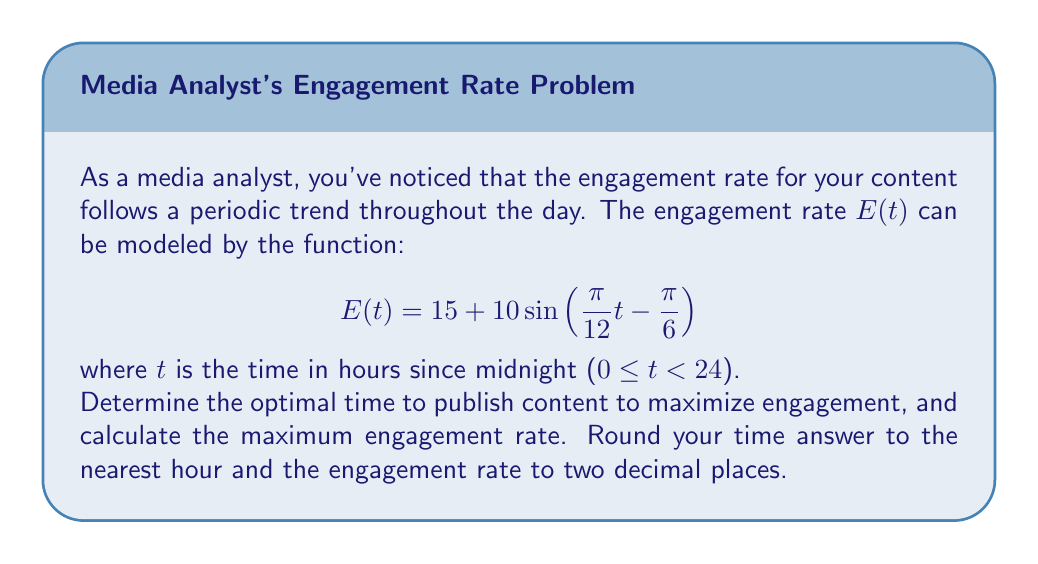Show me your answer to this math problem. To solve this problem, we'll follow these steps:

1) The function $E(t)$ is a sinusoidal function with a period of 24 hours. The optimal time to publish will be when this function reaches its maximum value.

2) For a sine function in the form $a\sin(bt - c) + d$, the maximum occurs when $bt - c = \frac{\pi}{2}$.

3) In our case, $b = \frac{\pi}{12}$, $c = \frac{\pi}{6}$, so we need to solve:

   $$\frac{\pi}{12}t - \frac{\pi}{6} = \frac{\pi}{2}$$

4) Solving for t:
   
   $$\frac{\pi}{12}t = \frac{\pi}{2} + \frac{\pi}{6} = \frac{2\pi}{3}$$
   
   $$t = \frac{2\pi}{3} \cdot \frac{12}{\pi} = 8$$

5) This means the optimal time is 8 hours after midnight, or 8:00 AM.

6) To find the maximum engagement rate, we substitute t = 8 into our original function:

   $$E(8) = 15 + 10\sin\left(\frac{\pi}{12}(8) - \frac{\pi}{6}\right)$$
   
   $$= 15 + 10\sin\left(\frac{2\pi}{3} - \frac{\pi}{6}\right)$$
   
   $$= 15 + 10\sin\left(\frac{\pi}{2}\right)$$
   
   $$= 15 + 10 = 25$$

Therefore, the maximum engagement rate is 25.00.
Answer: The optimal time to publish content is 8:00 AM, and the maximum engagement rate is 25.00. 